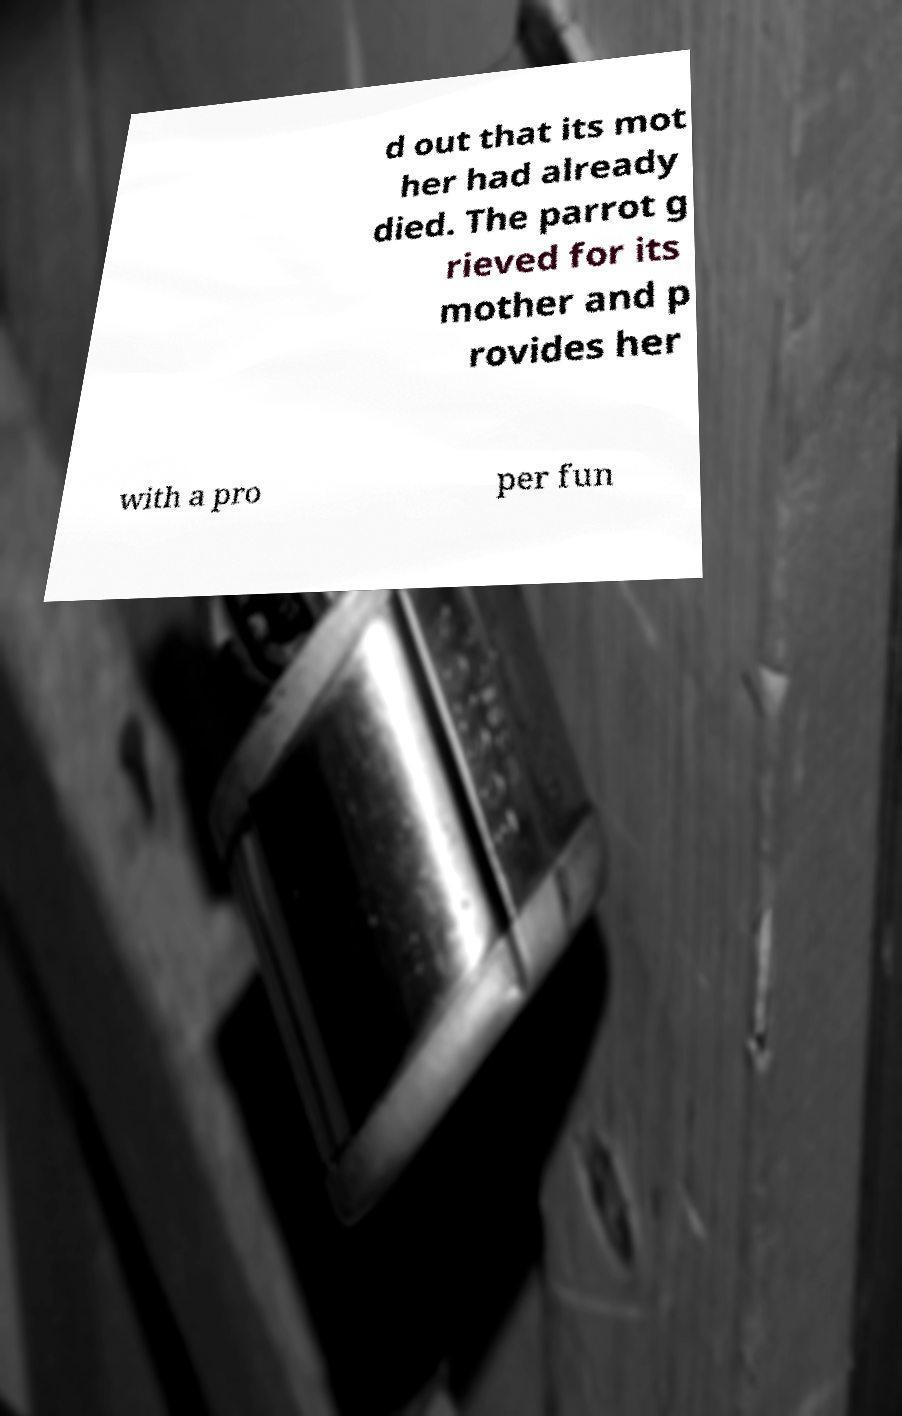For documentation purposes, I need the text within this image transcribed. Could you provide that? d out that its mot her had already died. The parrot g rieved for its mother and p rovides her with a pro per fun 